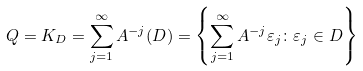Convert formula to latex. <formula><loc_0><loc_0><loc_500><loc_500>Q = K _ { D } = \sum _ { j = 1 } ^ { \infty } A ^ { - j } ( D ) = \left \{ \sum _ { j = 1 } ^ { \infty } A ^ { - j } \varepsilon _ { j } \colon \varepsilon _ { j } \in D \right \}</formula> 